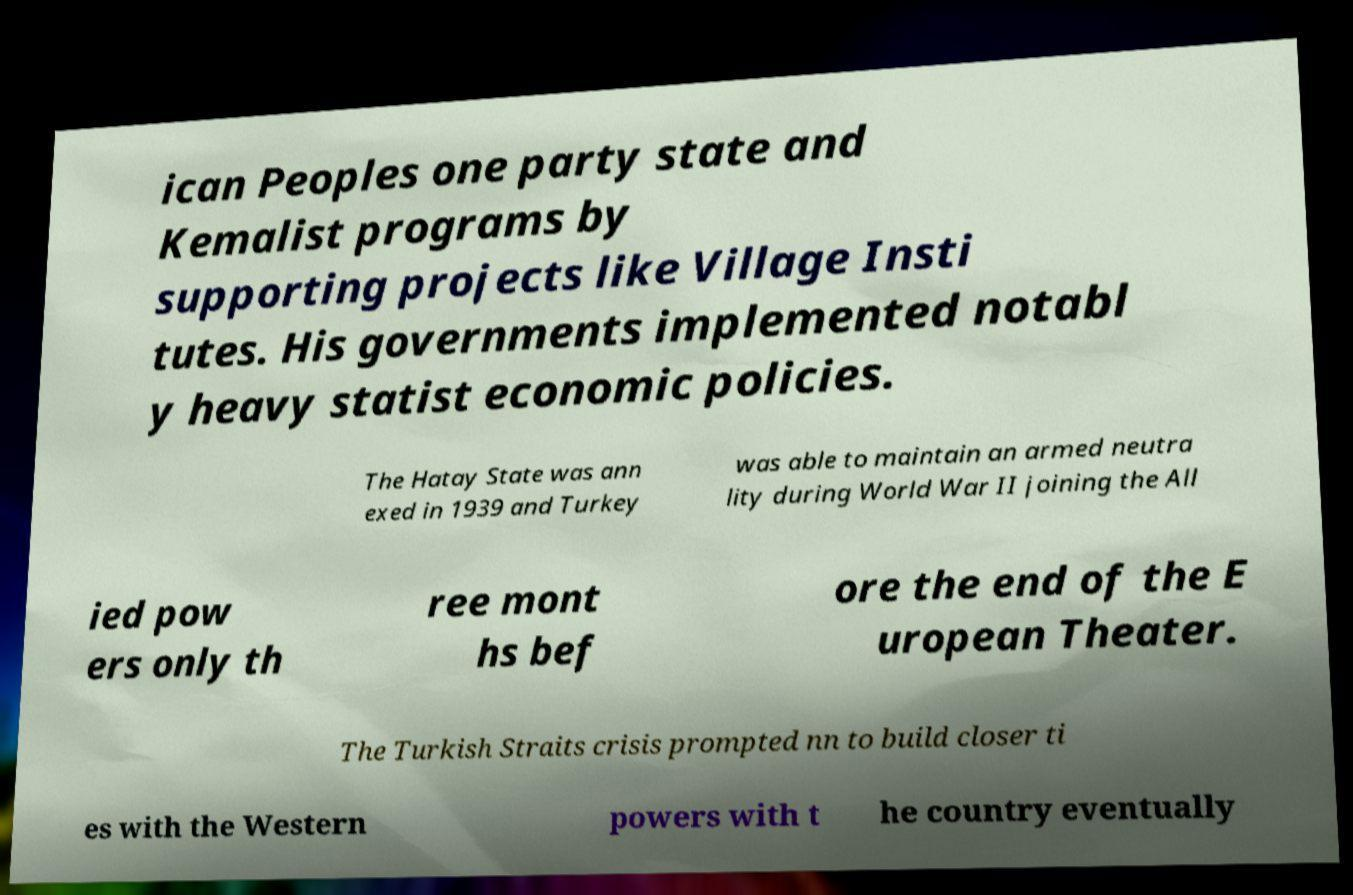Can you read and provide the text displayed in the image?This photo seems to have some interesting text. Can you extract and type it out for me? ican Peoples one party state and Kemalist programs by supporting projects like Village Insti tutes. His governments implemented notabl y heavy statist economic policies. The Hatay State was ann exed in 1939 and Turkey was able to maintain an armed neutra lity during World War II joining the All ied pow ers only th ree mont hs bef ore the end of the E uropean Theater. The Turkish Straits crisis prompted nn to build closer ti es with the Western powers with t he country eventually 